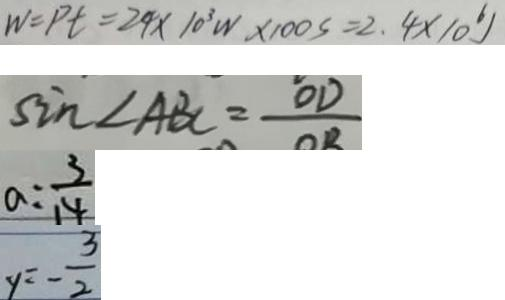Convert formula to latex. <formula><loc_0><loc_0><loc_500><loc_500>w = p t = 2 4 \times 1 0 ^ { 3 } W \times 1 0 0 s = 2 . 4 \times 1 0 ^ { 6 } 
 \sin \angle A B C = \frac { O D } { O B } 
 a = \frac { 3 } { 1 4 } 
 y = - \frac { 3 } { 2 }</formula> 